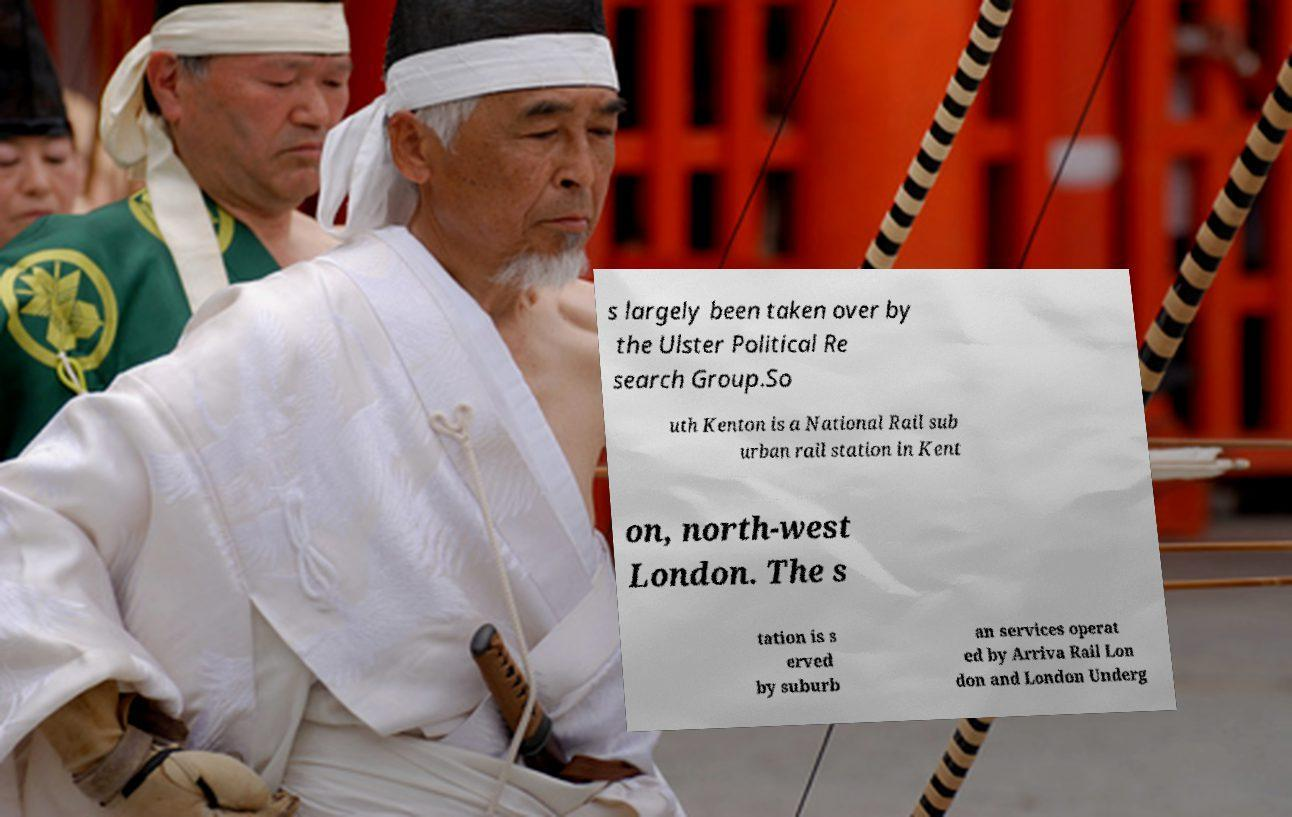Could you extract and type out the text from this image? s largely been taken over by the Ulster Political Re search Group.So uth Kenton is a National Rail sub urban rail station in Kent on, north-west London. The s tation is s erved by suburb an services operat ed by Arriva Rail Lon don and London Underg 